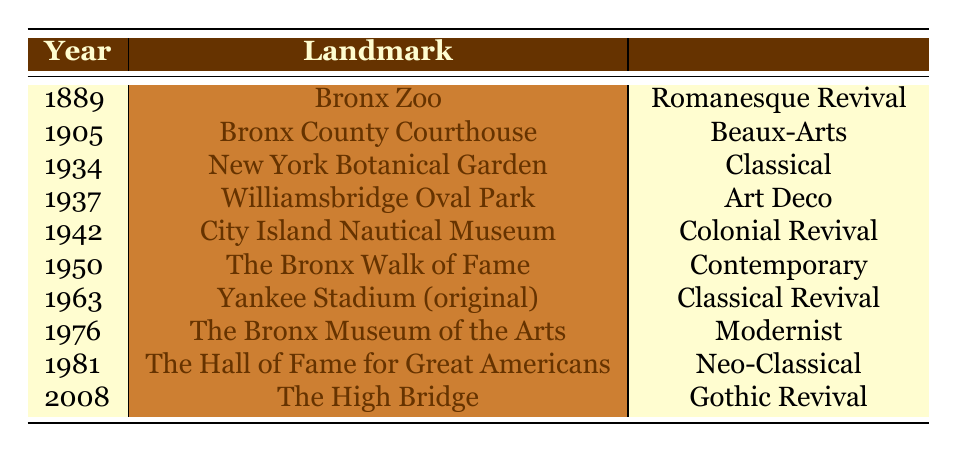What architectural style is the Bronx Zoo designed in? The Bronx Zoo was established in 1889, and its architectural style is listed as Romanesque Revival in the table.
Answer: Romanesque Revival Which landmark was built in 1942? According to the table, the City Island Nautical Museum is the only landmark listed that was established in the year 1942.
Answer: City Island Nautical Museum How many landmarks were established before 1930? The years before 1930 in the table are 1889 and 1905, which correspond to the Bronx Zoo and Bronx County Courthouse, respectively. This means there are 2 landmarks established before 1930.
Answer: 2 Is The High Bridge the most recently established landmark in the table? The High Bridge was established in 2008, and it is the only landmark from that year, making it the most recently established landmark in the list.
Answer: Yes Which architectural style appears the most frequently in the table? By examining the architectural styles in the table, we see Romanesque Revival, Beaux-Arts, Classical, Art Deco, Colonial Revival, Contemporary, Classical Revival, Modernist, Neo-Classical, and Gothic Revival. They all appear once, so there is no frequently appearing style.
Answer: None What is the difference in years between the oldest and the most recent landmark? The oldest landmark, Bronx Zoo, was established in 1889, and the most recent, The High Bridge, was established in 2008. The difference in years is calculated as 2008 - 1889 = 119.
Answer: 119 Which architectural styles were established in the 1930s? Observing the table, two landmarks were established in the 1930s: New York Botanical Garden in 1934 (Classical) and Williamsbridge Oval Park in 1937 (Art Deco). Thus, the architectural styles from the 1930s are Classical and Art Deco.
Answer: Classical, Art Deco How many landmarks have a Neo-Classical style? Upon reviewing the table, the only landmark with a Neo-Classical style is The Hall of Fame for Great Americans, which was established in 1981. Therefore, there is only one landmark with this style.
Answer: 1 Which year saw the establishment of the Bronx Museum of the Arts? From the table, it is clear that the Bronx Museum of the Arts was established in 1976.
Answer: 1976 